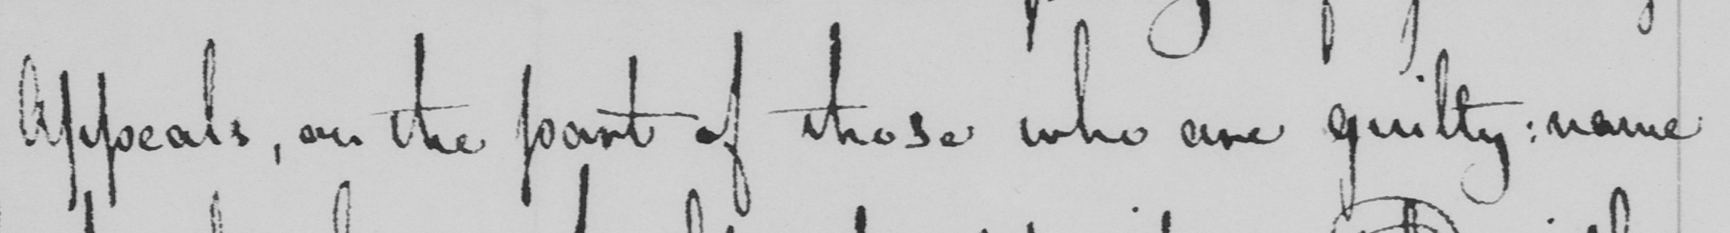Can you tell me what this handwritten text says? Appeals , on the part of those who are guilty :  name 